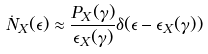<formula> <loc_0><loc_0><loc_500><loc_500>\dot { N } _ { X } ( \epsilon ) \approx \frac { P _ { X } ( \gamma ) } { \epsilon _ { X } ( \gamma ) } \delta ( \epsilon - \epsilon _ { X } ( \gamma ) )</formula> 